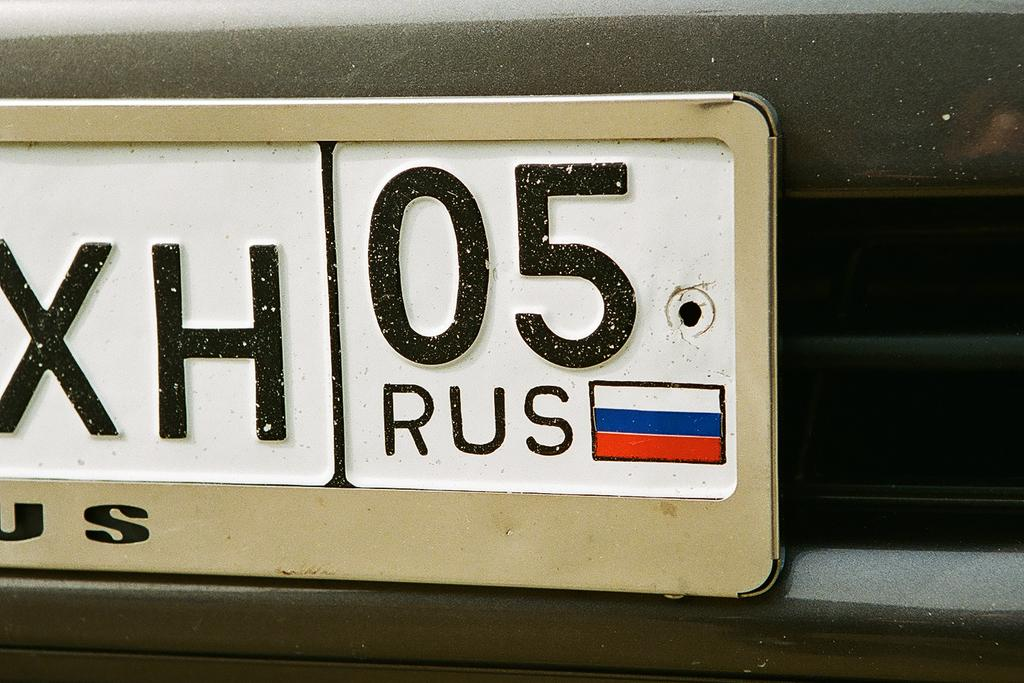Provide a one-sentence caption for the provided image. A real Russian license plate with the following numbers: XH05. 